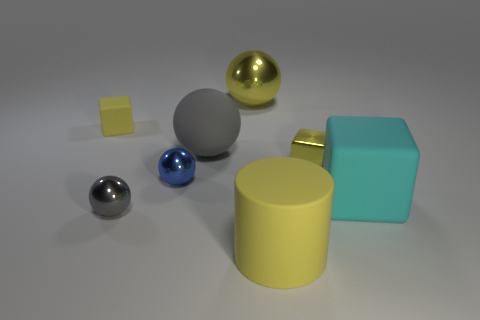Add 1 big matte spheres. How many objects exist? 9 Subtract all cubes. How many objects are left? 5 Subtract all blue things. Subtract all blue shiny spheres. How many objects are left? 6 Add 4 tiny blue shiny objects. How many tiny blue shiny objects are left? 5 Add 1 tiny blue metallic objects. How many tiny blue metallic objects exist? 2 Subtract 0 purple cylinders. How many objects are left? 8 